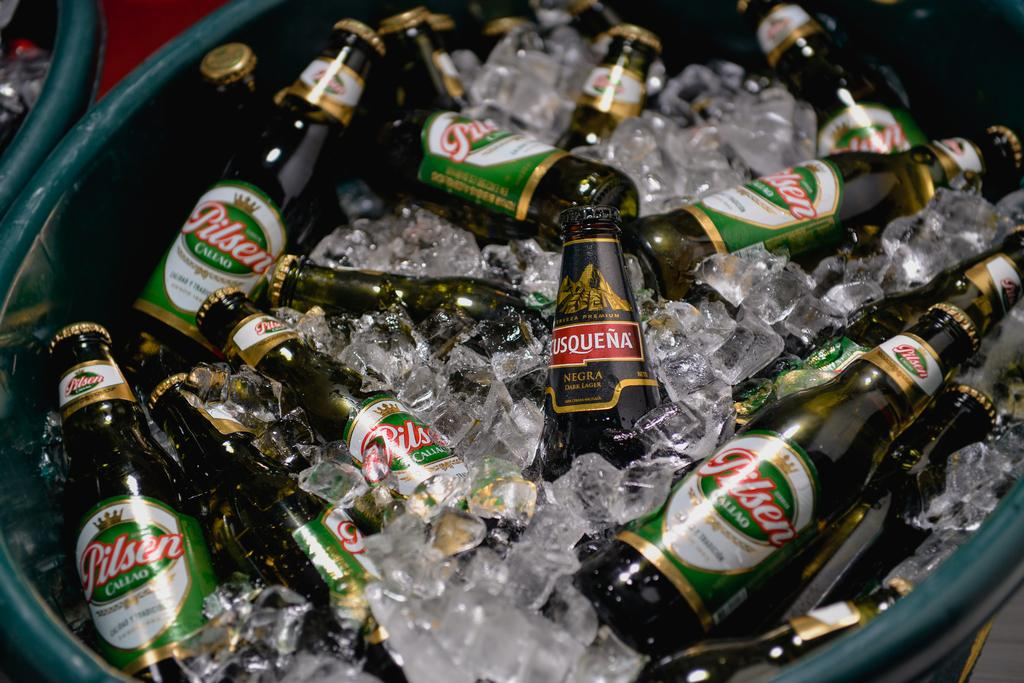<image>
Describe the image concisely. A green tub filled with bottles of Pilsen beer and ice. 